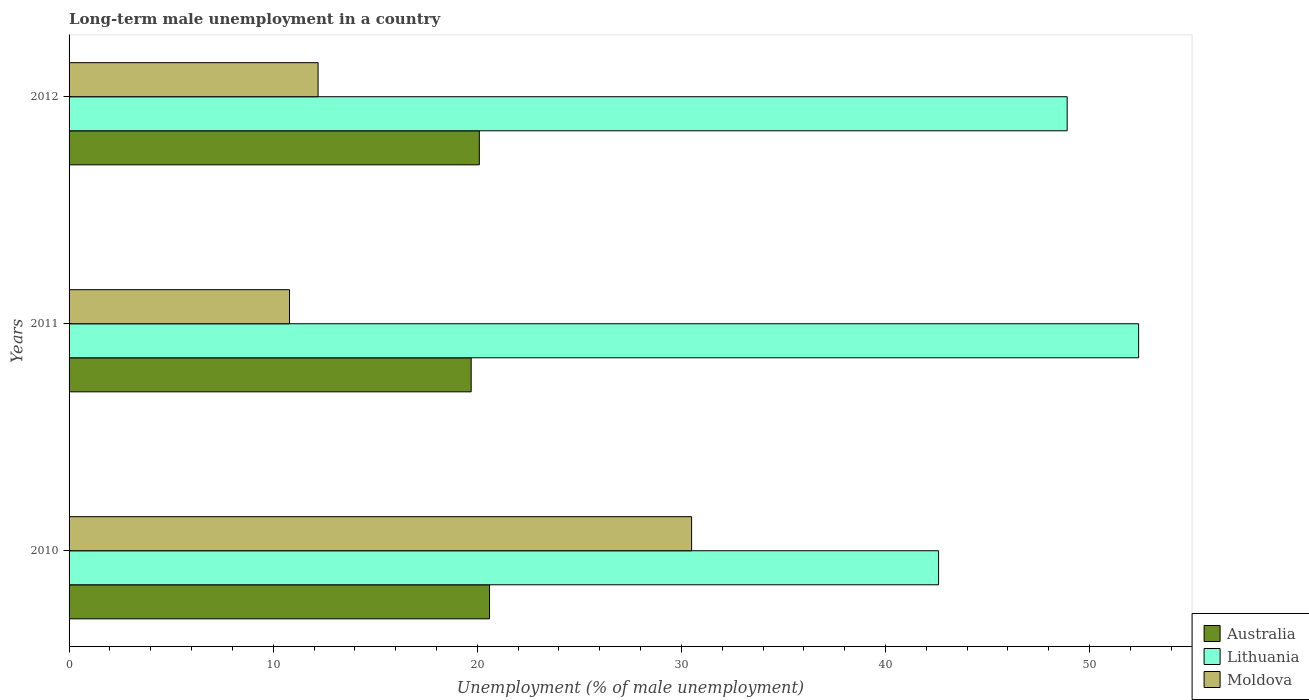How many different coloured bars are there?
Your response must be concise. 3. How many groups of bars are there?
Provide a succinct answer. 3. How many bars are there on the 2nd tick from the bottom?
Provide a succinct answer. 3. What is the percentage of long-term unemployed male population in Moldova in 2012?
Offer a very short reply. 12.2. Across all years, what is the maximum percentage of long-term unemployed male population in Australia?
Keep it short and to the point. 20.6. Across all years, what is the minimum percentage of long-term unemployed male population in Lithuania?
Give a very brief answer. 42.6. In which year was the percentage of long-term unemployed male population in Lithuania maximum?
Offer a very short reply. 2011. In which year was the percentage of long-term unemployed male population in Australia minimum?
Keep it short and to the point. 2011. What is the total percentage of long-term unemployed male population in Moldova in the graph?
Offer a terse response. 53.5. What is the difference between the percentage of long-term unemployed male population in Moldova in 2010 and that in 2012?
Offer a very short reply. 18.3. What is the difference between the percentage of long-term unemployed male population in Lithuania in 2010 and the percentage of long-term unemployed male population in Australia in 2012?
Offer a terse response. 22.5. What is the average percentage of long-term unemployed male population in Moldova per year?
Your answer should be very brief. 17.83. In the year 2011, what is the difference between the percentage of long-term unemployed male population in Australia and percentage of long-term unemployed male population in Moldova?
Ensure brevity in your answer.  8.9. In how many years, is the percentage of long-term unemployed male population in Moldova greater than 4 %?
Offer a very short reply. 3. What is the ratio of the percentage of long-term unemployed male population in Australia in 2010 to that in 2011?
Your answer should be very brief. 1.05. What is the difference between the highest and the second highest percentage of long-term unemployed male population in Moldova?
Keep it short and to the point. 18.3. What is the difference between the highest and the lowest percentage of long-term unemployed male population in Moldova?
Provide a succinct answer. 19.7. In how many years, is the percentage of long-term unemployed male population in Australia greater than the average percentage of long-term unemployed male population in Australia taken over all years?
Your response must be concise. 1. What does the 2nd bar from the top in 2010 represents?
Provide a succinct answer. Lithuania. What does the 2nd bar from the bottom in 2010 represents?
Provide a succinct answer. Lithuania. Is it the case that in every year, the sum of the percentage of long-term unemployed male population in Lithuania and percentage of long-term unemployed male population in Australia is greater than the percentage of long-term unemployed male population in Moldova?
Your response must be concise. Yes. Are all the bars in the graph horizontal?
Offer a terse response. Yes. How many years are there in the graph?
Your answer should be compact. 3. What is the difference between two consecutive major ticks on the X-axis?
Offer a very short reply. 10. Are the values on the major ticks of X-axis written in scientific E-notation?
Offer a very short reply. No. Does the graph contain any zero values?
Keep it short and to the point. No. Where does the legend appear in the graph?
Ensure brevity in your answer.  Bottom right. What is the title of the graph?
Your answer should be compact. Long-term male unemployment in a country. What is the label or title of the X-axis?
Your response must be concise. Unemployment (% of male unemployment). What is the label or title of the Y-axis?
Your response must be concise. Years. What is the Unemployment (% of male unemployment) of Australia in 2010?
Your answer should be very brief. 20.6. What is the Unemployment (% of male unemployment) of Lithuania in 2010?
Keep it short and to the point. 42.6. What is the Unemployment (% of male unemployment) of Moldova in 2010?
Provide a succinct answer. 30.5. What is the Unemployment (% of male unemployment) of Australia in 2011?
Offer a very short reply. 19.7. What is the Unemployment (% of male unemployment) of Lithuania in 2011?
Offer a very short reply. 52.4. What is the Unemployment (% of male unemployment) of Moldova in 2011?
Keep it short and to the point. 10.8. What is the Unemployment (% of male unemployment) of Australia in 2012?
Your answer should be very brief. 20.1. What is the Unemployment (% of male unemployment) in Lithuania in 2012?
Your answer should be compact. 48.9. What is the Unemployment (% of male unemployment) in Moldova in 2012?
Your answer should be compact. 12.2. Across all years, what is the maximum Unemployment (% of male unemployment) in Australia?
Keep it short and to the point. 20.6. Across all years, what is the maximum Unemployment (% of male unemployment) of Lithuania?
Your answer should be compact. 52.4. Across all years, what is the maximum Unemployment (% of male unemployment) in Moldova?
Your answer should be compact. 30.5. Across all years, what is the minimum Unemployment (% of male unemployment) in Australia?
Provide a short and direct response. 19.7. Across all years, what is the minimum Unemployment (% of male unemployment) in Lithuania?
Provide a succinct answer. 42.6. Across all years, what is the minimum Unemployment (% of male unemployment) in Moldova?
Provide a succinct answer. 10.8. What is the total Unemployment (% of male unemployment) in Australia in the graph?
Keep it short and to the point. 60.4. What is the total Unemployment (% of male unemployment) of Lithuania in the graph?
Your answer should be compact. 143.9. What is the total Unemployment (% of male unemployment) in Moldova in the graph?
Keep it short and to the point. 53.5. What is the difference between the Unemployment (% of male unemployment) of Lithuania in 2010 and that in 2011?
Offer a terse response. -9.8. What is the difference between the Unemployment (% of male unemployment) of Lithuania in 2010 and that in 2012?
Your answer should be very brief. -6.3. What is the difference between the Unemployment (% of male unemployment) in Australia in 2010 and the Unemployment (% of male unemployment) in Lithuania in 2011?
Ensure brevity in your answer.  -31.8. What is the difference between the Unemployment (% of male unemployment) in Australia in 2010 and the Unemployment (% of male unemployment) in Moldova in 2011?
Your answer should be very brief. 9.8. What is the difference between the Unemployment (% of male unemployment) in Lithuania in 2010 and the Unemployment (% of male unemployment) in Moldova in 2011?
Offer a very short reply. 31.8. What is the difference between the Unemployment (% of male unemployment) in Australia in 2010 and the Unemployment (% of male unemployment) in Lithuania in 2012?
Offer a terse response. -28.3. What is the difference between the Unemployment (% of male unemployment) in Lithuania in 2010 and the Unemployment (% of male unemployment) in Moldova in 2012?
Provide a succinct answer. 30.4. What is the difference between the Unemployment (% of male unemployment) in Australia in 2011 and the Unemployment (% of male unemployment) in Lithuania in 2012?
Offer a terse response. -29.2. What is the difference between the Unemployment (% of male unemployment) in Australia in 2011 and the Unemployment (% of male unemployment) in Moldova in 2012?
Keep it short and to the point. 7.5. What is the difference between the Unemployment (% of male unemployment) in Lithuania in 2011 and the Unemployment (% of male unemployment) in Moldova in 2012?
Provide a short and direct response. 40.2. What is the average Unemployment (% of male unemployment) in Australia per year?
Make the answer very short. 20.13. What is the average Unemployment (% of male unemployment) in Lithuania per year?
Provide a short and direct response. 47.97. What is the average Unemployment (% of male unemployment) in Moldova per year?
Provide a short and direct response. 17.83. In the year 2010, what is the difference between the Unemployment (% of male unemployment) of Australia and Unemployment (% of male unemployment) of Lithuania?
Give a very brief answer. -22. In the year 2010, what is the difference between the Unemployment (% of male unemployment) in Australia and Unemployment (% of male unemployment) in Moldova?
Your answer should be very brief. -9.9. In the year 2011, what is the difference between the Unemployment (% of male unemployment) in Australia and Unemployment (% of male unemployment) in Lithuania?
Ensure brevity in your answer.  -32.7. In the year 2011, what is the difference between the Unemployment (% of male unemployment) of Lithuania and Unemployment (% of male unemployment) of Moldova?
Your answer should be compact. 41.6. In the year 2012, what is the difference between the Unemployment (% of male unemployment) of Australia and Unemployment (% of male unemployment) of Lithuania?
Provide a short and direct response. -28.8. In the year 2012, what is the difference between the Unemployment (% of male unemployment) in Lithuania and Unemployment (% of male unemployment) in Moldova?
Your response must be concise. 36.7. What is the ratio of the Unemployment (% of male unemployment) of Australia in 2010 to that in 2011?
Provide a succinct answer. 1.05. What is the ratio of the Unemployment (% of male unemployment) in Lithuania in 2010 to that in 2011?
Offer a very short reply. 0.81. What is the ratio of the Unemployment (% of male unemployment) of Moldova in 2010 to that in 2011?
Your answer should be compact. 2.82. What is the ratio of the Unemployment (% of male unemployment) of Australia in 2010 to that in 2012?
Your answer should be very brief. 1.02. What is the ratio of the Unemployment (% of male unemployment) of Lithuania in 2010 to that in 2012?
Give a very brief answer. 0.87. What is the ratio of the Unemployment (% of male unemployment) in Moldova in 2010 to that in 2012?
Ensure brevity in your answer.  2.5. What is the ratio of the Unemployment (% of male unemployment) of Australia in 2011 to that in 2012?
Offer a very short reply. 0.98. What is the ratio of the Unemployment (% of male unemployment) in Lithuania in 2011 to that in 2012?
Your response must be concise. 1.07. What is the ratio of the Unemployment (% of male unemployment) in Moldova in 2011 to that in 2012?
Give a very brief answer. 0.89. What is the difference between the highest and the second highest Unemployment (% of male unemployment) in Lithuania?
Keep it short and to the point. 3.5. What is the difference between the highest and the lowest Unemployment (% of male unemployment) in Lithuania?
Offer a terse response. 9.8. 